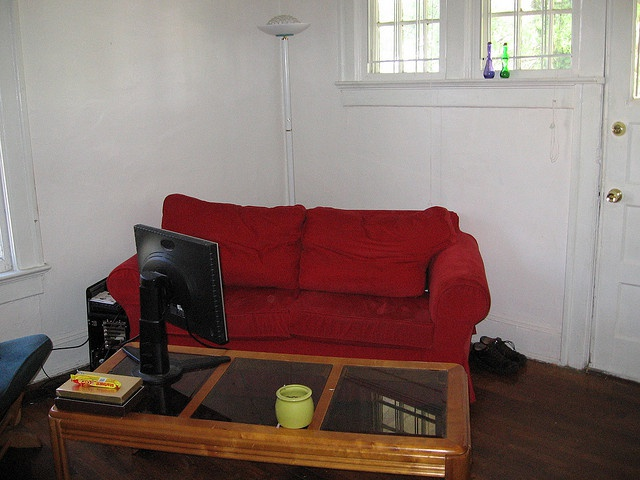Describe the objects in this image and their specific colors. I can see couch in gray, maroon, brown, black, and darkgray tones, tv in gray, black, and maroon tones, chair in gray, black, and blue tones, book in gray, tan, maroon, brown, and black tones, and vase in gray and olive tones in this image. 